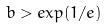<formula> <loc_0><loc_0><loc_500><loc_500>b > e x p ( 1 / e )</formula> 